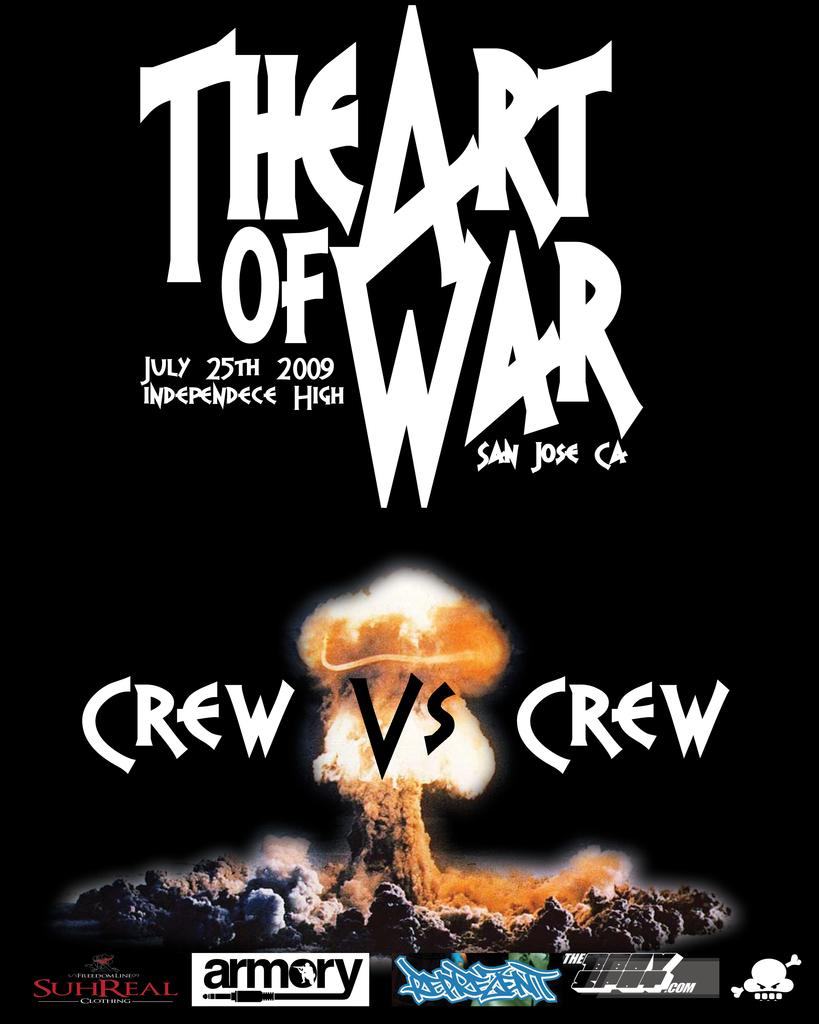<image>
Summarize the visual content of the image. A poster for The Art of War with "Crew vs Crew" written below it. 